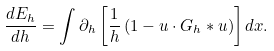Convert formula to latex. <formula><loc_0><loc_0><loc_500><loc_500>\frac { d E _ { h } } { d h } = \int \partial _ { h } \left [ \frac { 1 } { h } \left ( 1 - u \cdot G _ { h } \ast u \right ) \right ] d x .</formula> 